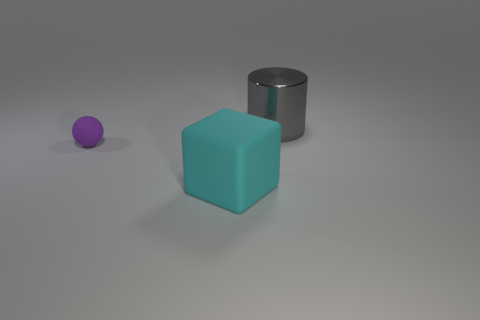Is there any other thing that is the same material as the big gray thing?
Make the answer very short. No. Are there any other things that are the same size as the purple ball?
Make the answer very short. No. What number of things are either things that are in front of the large metallic cylinder or large objects that are behind the large cyan thing?
Your response must be concise. 3. There is a cylinder that is the same size as the cyan rubber cube; what material is it?
Provide a succinct answer. Metal. The large matte object has what color?
Your response must be concise. Cyan. What material is the object that is both to the right of the purple object and in front of the gray thing?
Give a very brief answer. Rubber. Are there any large shiny objects that are in front of the object that is on the left side of the big thing that is left of the metallic object?
Ensure brevity in your answer.  No. There is a large cyan object; are there any big cubes behind it?
Ensure brevity in your answer.  No. What number of other things are there of the same shape as the purple object?
Provide a short and direct response. 0. There is a matte block that is the same size as the metal thing; what is its color?
Make the answer very short. Cyan. 